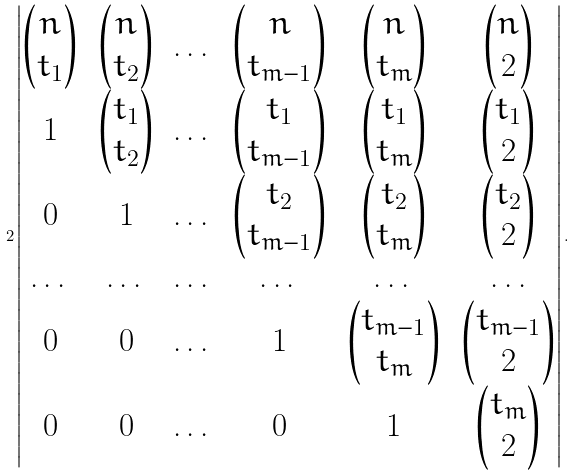Convert formula to latex. <formula><loc_0><loc_0><loc_500><loc_500>2 \left | \begin{matrix} \begin{pmatrix} n \\ t _ { 1 } \end{pmatrix} & \begin{pmatrix} n \\ t _ { 2 } \end{pmatrix} & \dots & \begin{pmatrix} n \\ t _ { m - 1 } \end{pmatrix} & \begin{pmatrix} n \\ t _ { m } \end{pmatrix} & \begin{pmatrix} n \\ 2 \end{pmatrix} \\ 1 & \begin{pmatrix} t _ { 1 } \\ t _ { 2 } \end{pmatrix} & \dots & \begin{pmatrix} t _ { 1 } \\ t _ { m - 1 } \end{pmatrix} & \begin{pmatrix} t _ { 1 } \\ t _ { m } \end{pmatrix} & \begin{pmatrix} t _ { 1 } \\ 2 \end{pmatrix} \\ 0 & 1 & \dots & \begin{pmatrix} t _ { 2 } \\ t _ { m - 1 } \end{pmatrix} & \begin{pmatrix} t _ { 2 } \\ t _ { m } \end{pmatrix} & \begin{pmatrix} t _ { 2 } \\ 2 \end{pmatrix} \\ \dots & \dots & \dots & \dots & \dots & \dots \\ 0 & 0 & \dots & 1 & \begin{pmatrix} t _ { m - 1 } \\ t _ { m } \end{pmatrix} & \begin{pmatrix} t _ { m - 1 } \\ 2 \end{pmatrix} \\ 0 & 0 & \dots & 0 & 1 & \begin{pmatrix} t _ { m } \\ 2 \end{pmatrix} \end{matrix} \right | .</formula> 